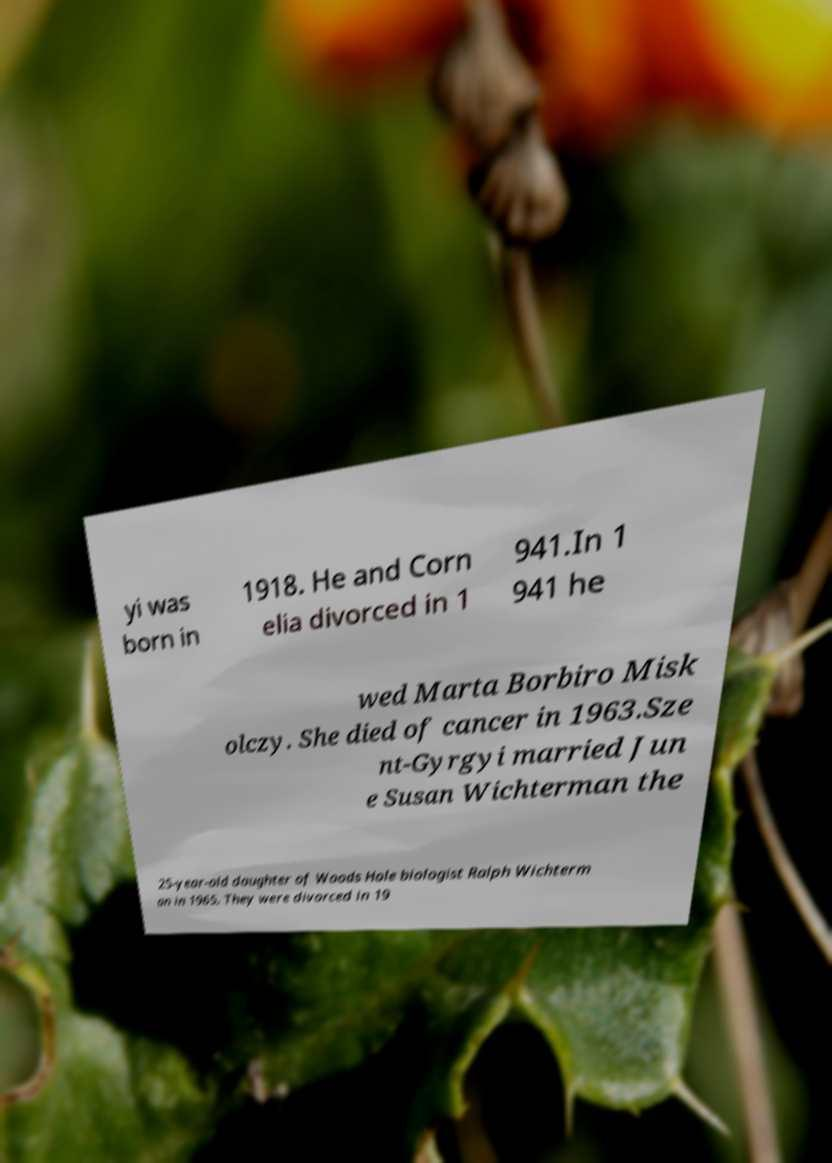There's text embedded in this image that I need extracted. Can you transcribe it verbatim? yi was born in 1918. He and Corn elia divorced in 1 941.In 1 941 he wed Marta Borbiro Misk olczy. She died of cancer in 1963.Sze nt-Gyrgyi married Jun e Susan Wichterman the 25-year-old daughter of Woods Hole biologist Ralph Wichterm an in 1965. They were divorced in 19 